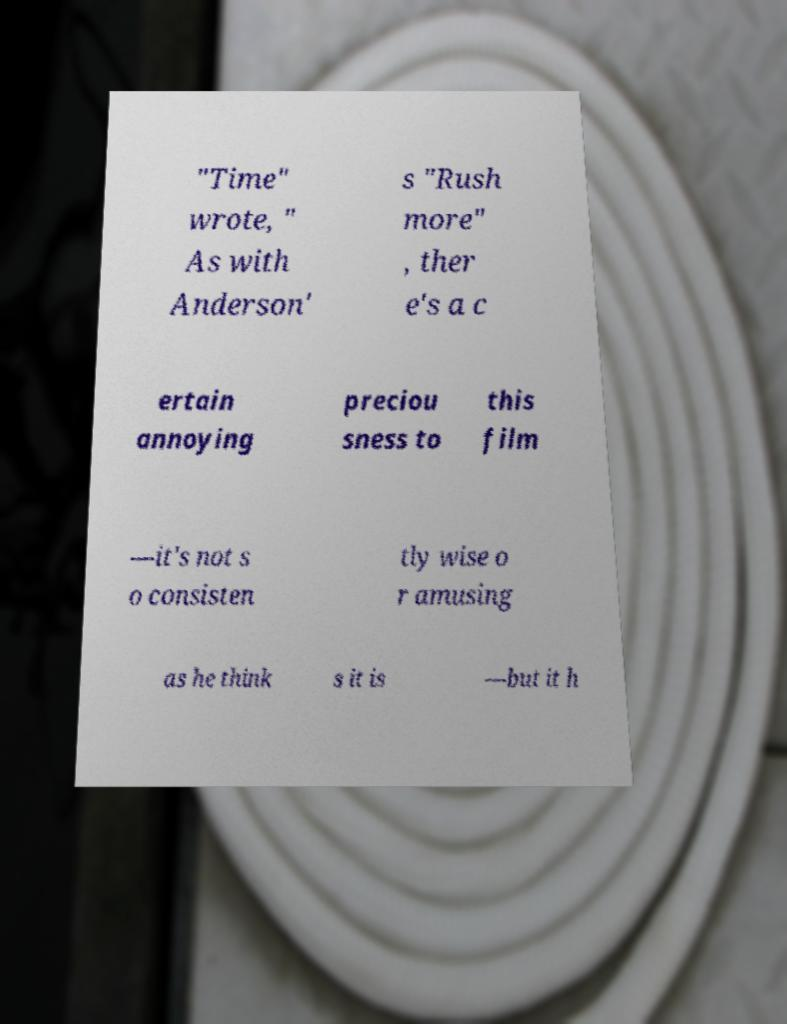Please read and relay the text visible in this image. What does it say? "Time" wrote, " As with Anderson' s "Rush more" , ther e's a c ertain annoying preciou sness to this film —it's not s o consisten tly wise o r amusing as he think s it is —but it h 